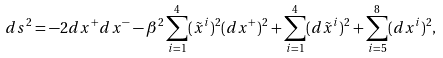<formula> <loc_0><loc_0><loc_500><loc_500>d s ^ { 2 } = - 2 d x ^ { + } d x ^ { - } - \beta ^ { 2 } \sum _ { i = 1 } ^ { 4 } ( \tilde { x } ^ { i } ) ^ { 2 } ( d x ^ { + } ) ^ { 2 } + \sum _ { i = 1 } ^ { 4 } ( d \tilde { x } ^ { i } ) ^ { 2 } + \sum _ { i = 5 } ^ { 8 } ( d x ^ { i } ) ^ { 2 } ,</formula> 